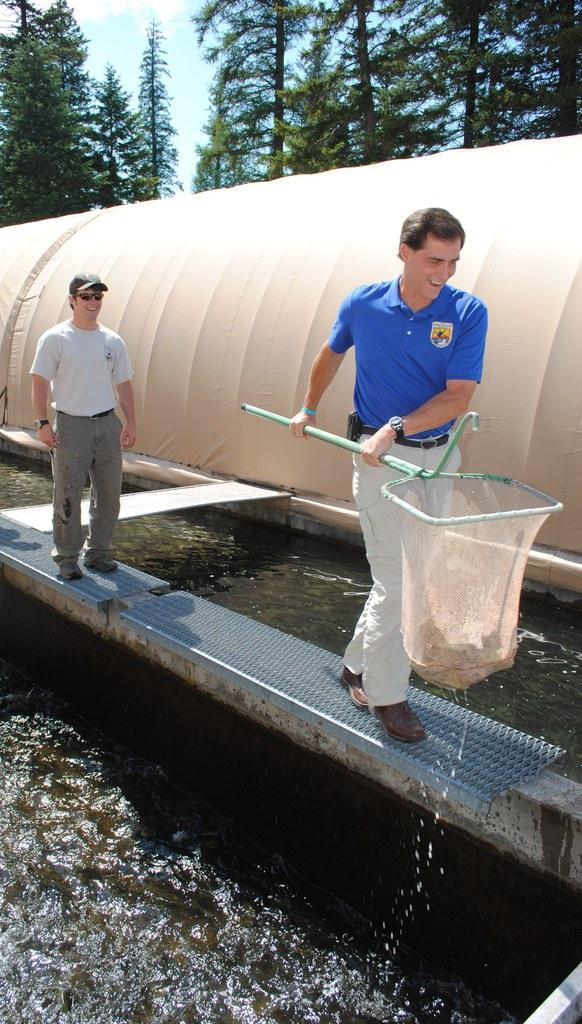How many people are in the image? There are two men in the image. What is one of the men holding? One of the men is holding a fishing net. What type of environment is depicted in the image? There is water and trees visible in the image, suggesting a natural setting. What else can be seen in the image besides the men and the fishing net? There are objects in the image, but their specific nature is not mentioned in the facts. What is visible in the background of the image? The sky is visible in the background of the image. What type of wristwatch is the man wearing in the image? There is no mention of a wristwatch or any type of accessory worn by the men in the image. 